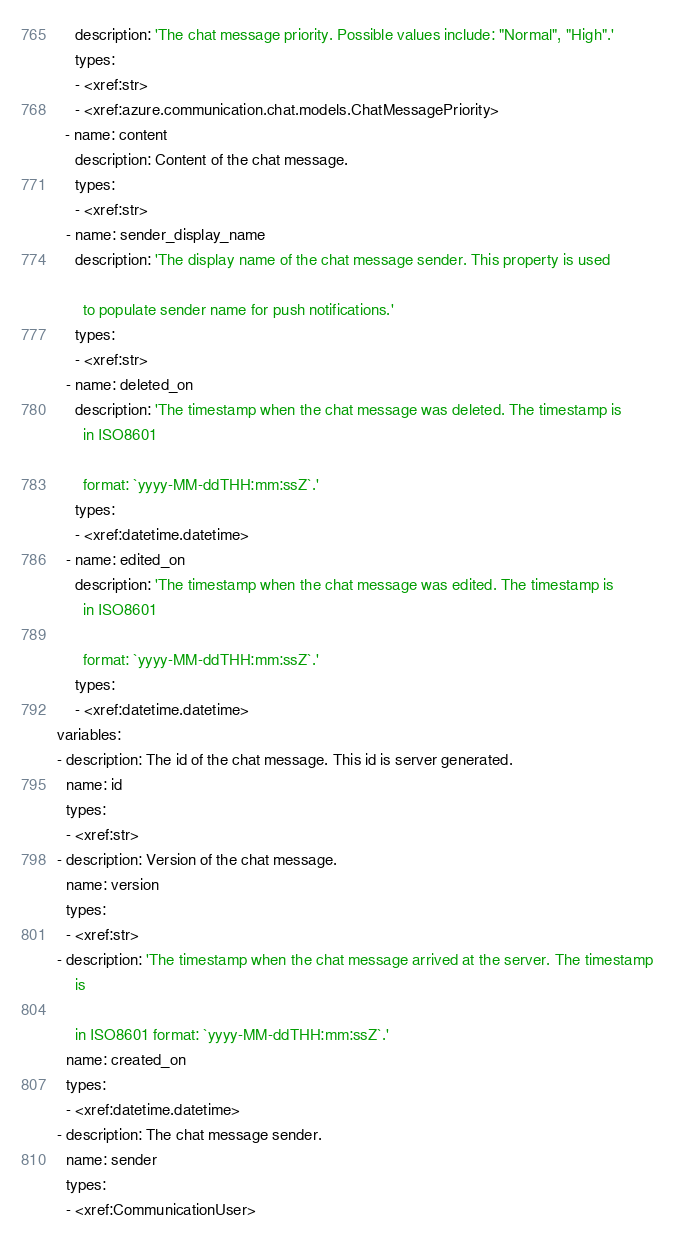<code> <loc_0><loc_0><loc_500><loc_500><_YAML_>    description: 'The chat message priority. Possible values include: "Normal", "High".'
    types:
    - <xref:str>
    - <xref:azure.communication.chat.models.ChatMessagePriority>
  - name: content
    description: Content of the chat message.
    types:
    - <xref:str>
  - name: sender_display_name
    description: 'The display name of the chat message sender. This property is used

      to populate sender name for push notifications.'
    types:
    - <xref:str>
  - name: deleted_on
    description: 'The timestamp when the chat message was deleted. The timestamp is
      in ISO8601

      format: `yyyy-MM-ddTHH:mm:ssZ`.'
    types:
    - <xref:datetime.datetime>
  - name: edited_on
    description: 'The timestamp when the chat message was edited. The timestamp is
      in ISO8601

      format: `yyyy-MM-ddTHH:mm:ssZ`.'
    types:
    - <xref:datetime.datetime>
variables:
- description: The id of the chat message. This id is server generated.
  name: id
  types:
  - <xref:str>
- description: Version of the chat message.
  name: version
  types:
  - <xref:str>
- description: 'The timestamp when the chat message arrived at the server. The timestamp
    is

    in ISO8601 format: `yyyy-MM-ddTHH:mm:ssZ`.'
  name: created_on
  types:
  - <xref:datetime.datetime>
- description: The chat message sender.
  name: sender
  types:
  - <xref:CommunicationUser>
</code> 